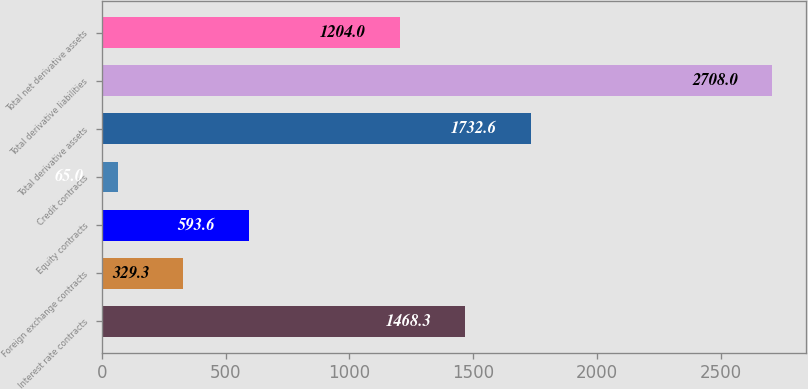<chart> <loc_0><loc_0><loc_500><loc_500><bar_chart><fcel>Interest rate contracts<fcel>Foreign exchange contracts<fcel>Equity contracts<fcel>Credit contracts<fcel>Total derivative assets<fcel>Total derivative liabilities<fcel>Total net derivative assets<nl><fcel>1468.3<fcel>329.3<fcel>593.6<fcel>65<fcel>1732.6<fcel>2708<fcel>1204<nl></chart> 